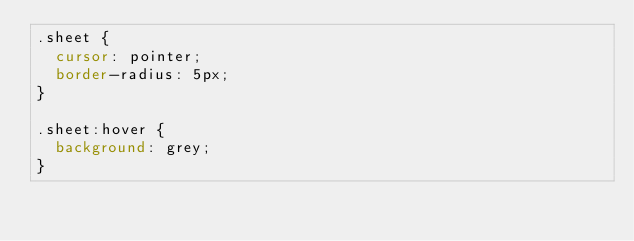<code> <loc_0><loc_0><loc_500><loc_500><_CSS_>.sheet {
	cursor: pointer;
	border-radius: 5px;
}

.sheet:hover {
	background: grey;
}
</code> 